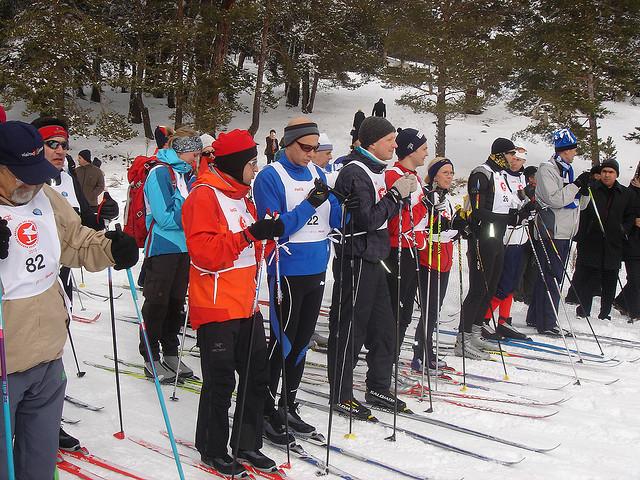Are all the skiers females?
Write a very short answer. No. What event is being held?
Quick response, please. Ski race. What color pants does number 39 have on?
Write a very short answer. Black. Is number 82 a man or a woman?
Keep it brief. Man. How many pairs of skis are there?
Give a very brief answer. 10. 